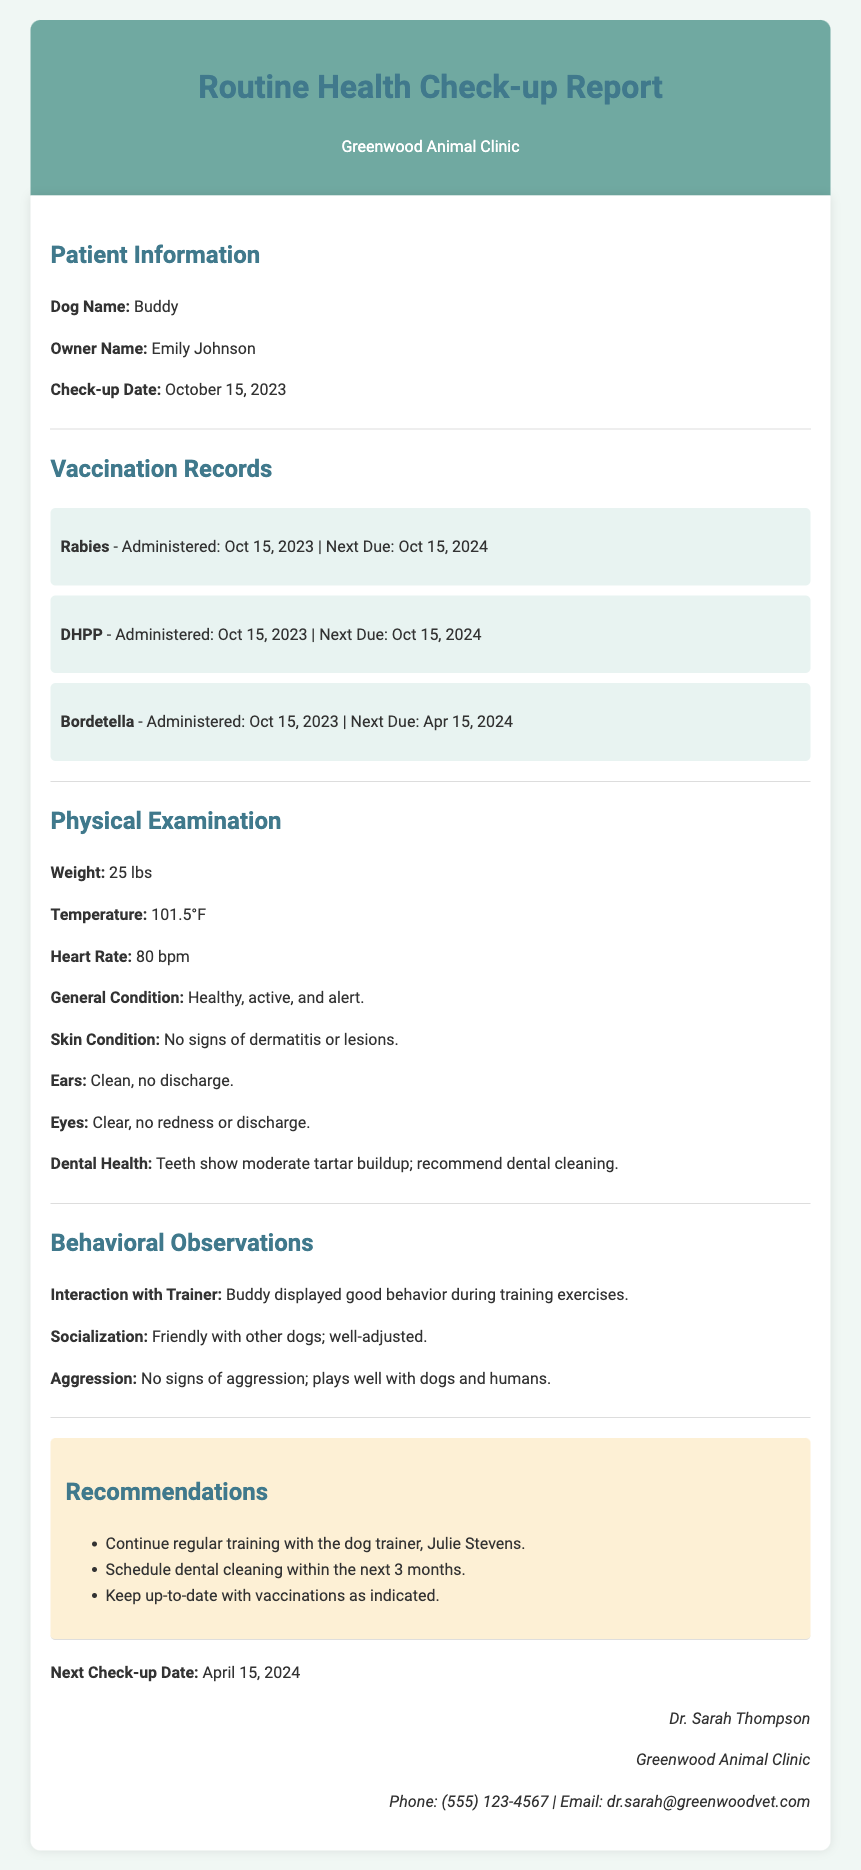What is the dog's name? The dog's name is listed at the beginning of the report under Patient Information.
Answer: Buddy Who is the owner of the dog? The owner's name is provided in the Patient Information section.
Answer: Emily Johnson When was the last check-up performed? The check-up date is specified in the report.
Answer: October 15, 2023 What vaccine was administered on October 15, 2023, that needs renewal next year? This vaccine is indicated in the Vaccination Records section with its due date.
Answer: Rabies What is Buddy's weight? The dog's weight is mentioned in the Physical Examination section.
Answer: 25 lbs What are the recommendations for Buddy's dental health? The recommendations are found in the Recommendations section, which outlines the need for dental care.
Answer: Schedule dental cleaning within the next 3 months Who performed the veterinary check-up? The veterinarian's name is mentioned at the end of the document.
Answer: Dr. Sarah Thompson What is the next check-up date for Buddy? The next check-up date is specified in the last part of the report.
Answer: April 15, 2024 How did Buddy behave during training sessions? This information is found under the Behavioral Observations section.
Answer: Good behavior 